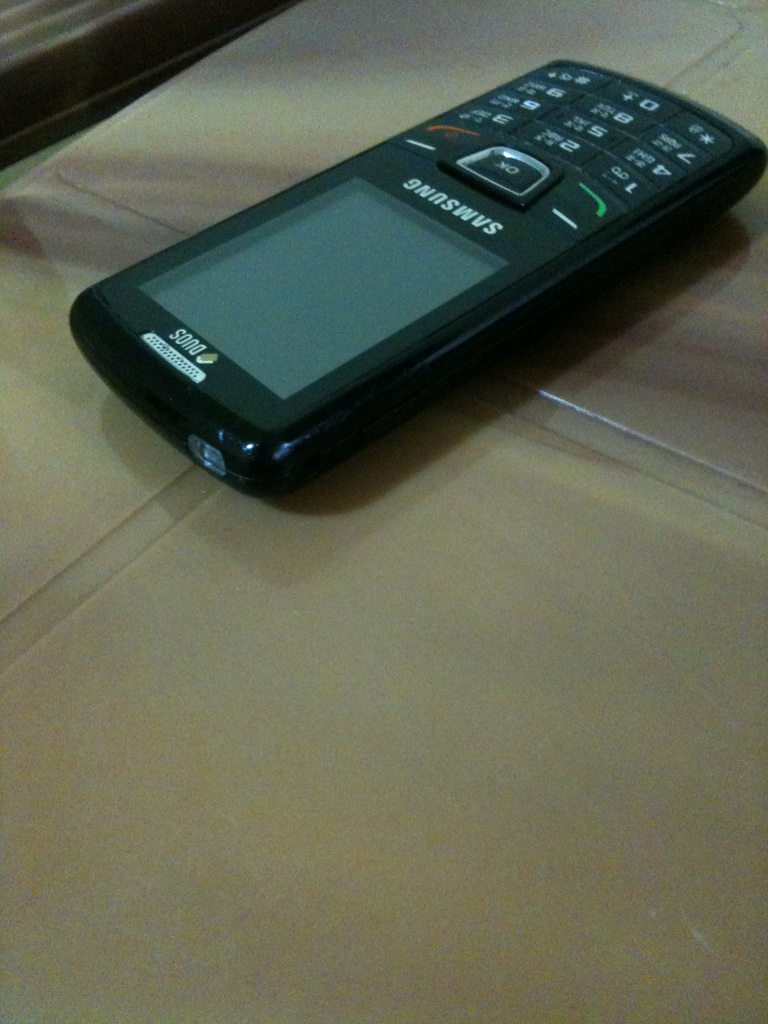Can you tell what kind of features this phone might have? This feature phone likely includes basic functionalities like calling, texting, a simple camera, FM radio, and possibly basic internet services, but it wouldn't support advanced apps or touch screen capabilities. 